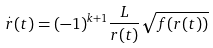<formula> <loc_0><loc_0><loc_500><loc_500>\overset { . } { r } ( t ) = ( - 1 ) ^ { k + 1 } \frac { L } { r ( t ) } \sqrt { f ( r ( t ) ) }</formula> 